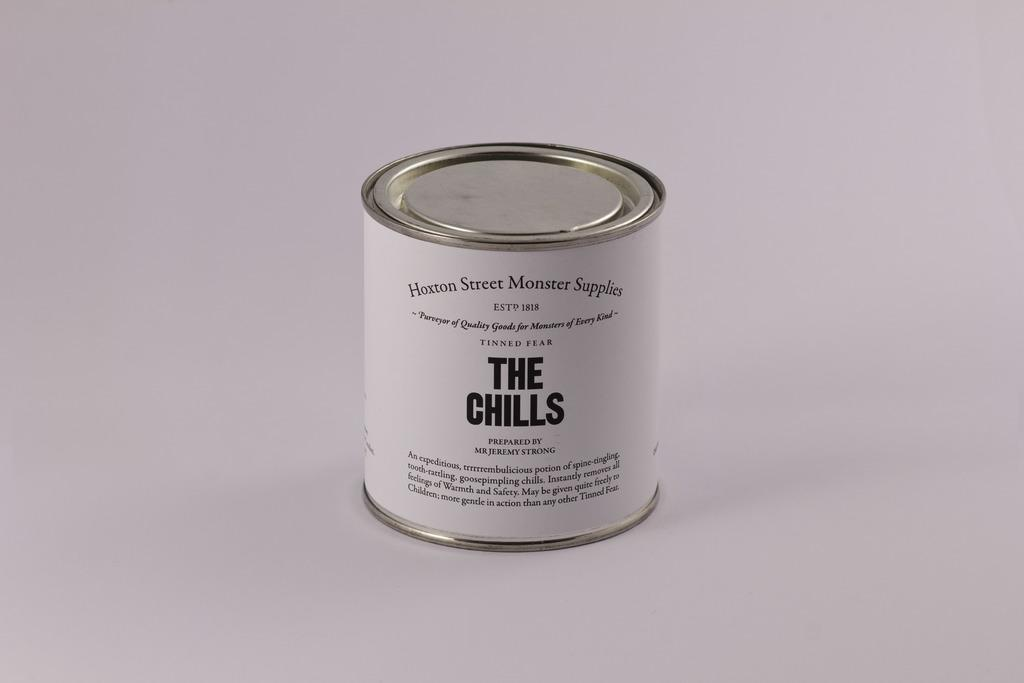<image>
Offer a succinct explanation of the picture presented. A can of what looks like paint that is called The Chills. 